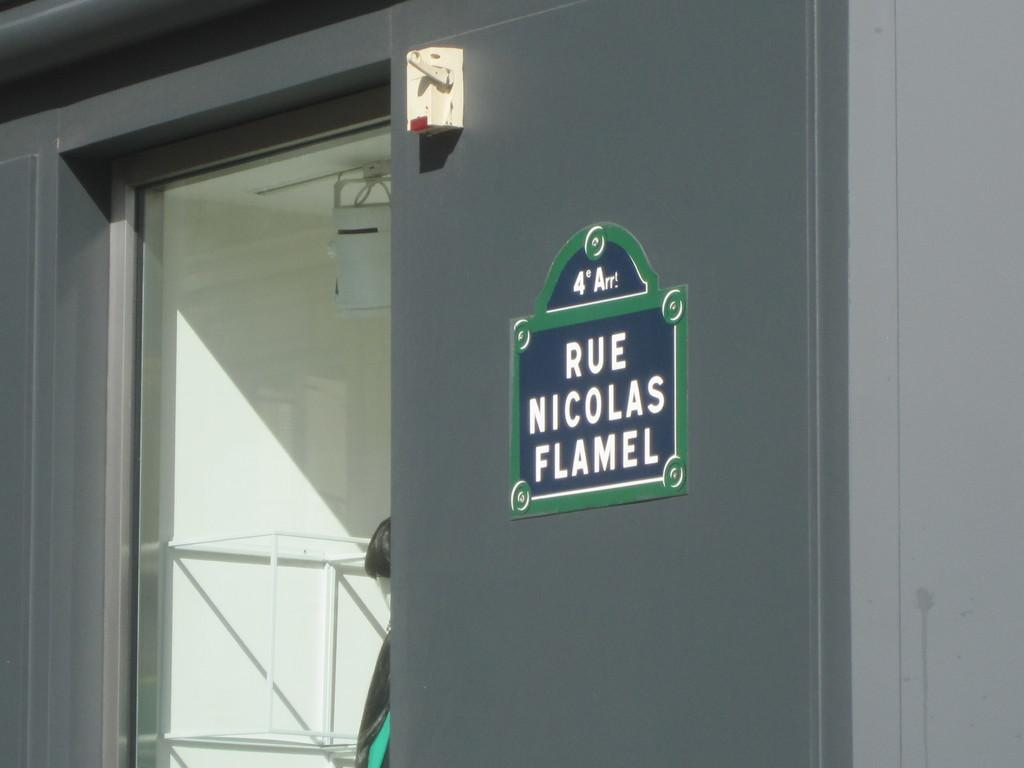What color is the wall in the image? The wall in the image is grey. What is placed in front of the wall? There is a board with text in front of the wall. What separates the wall and the board? There is glass between the wall and the board. What historical event is depicted in the scene in the image? There is no scene or historical event depicted in the image; it only features a grey wall, a board with text, and glass. 